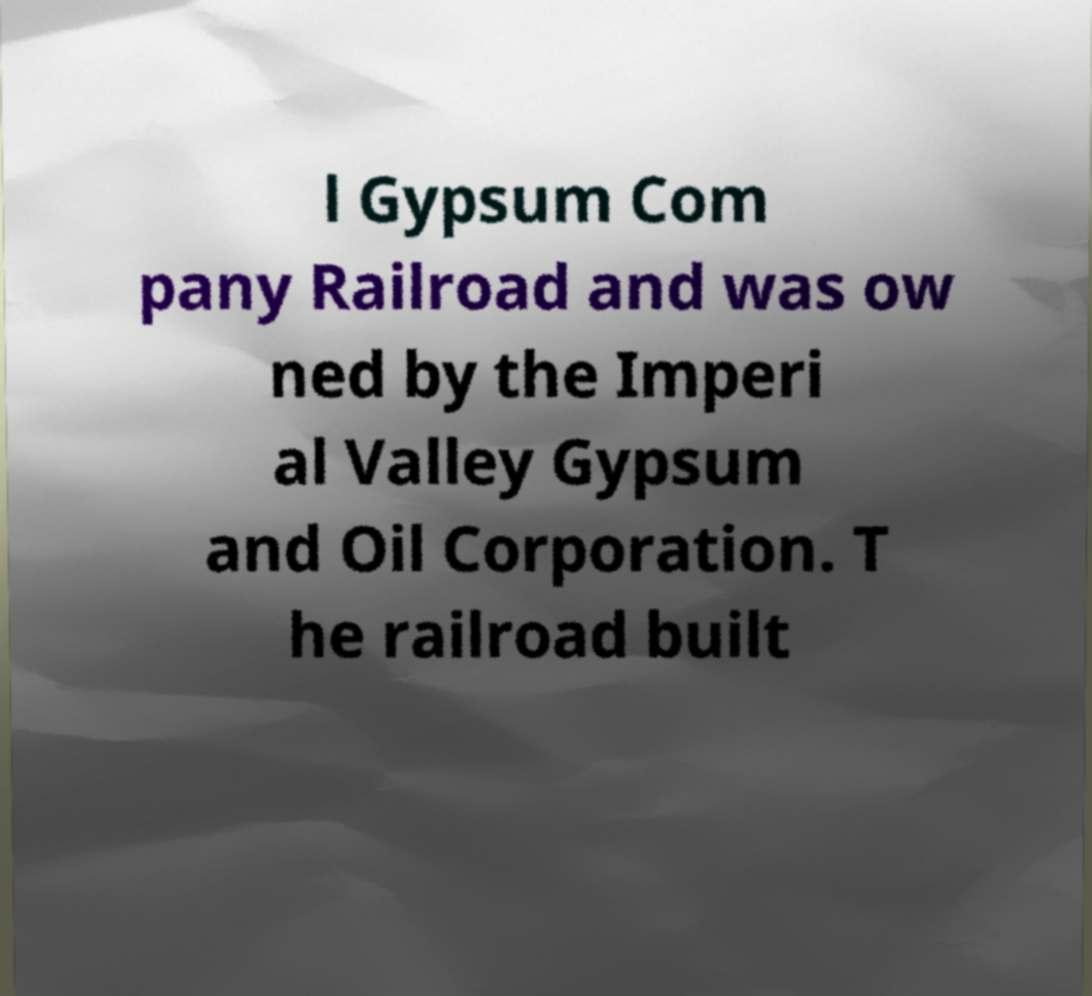Could you extract and type out the text from this image? l Gypsum Com pany Railroad and was ow ned by the Imperi al Valley Gypsum and Oil Corporation. T he railroad built 